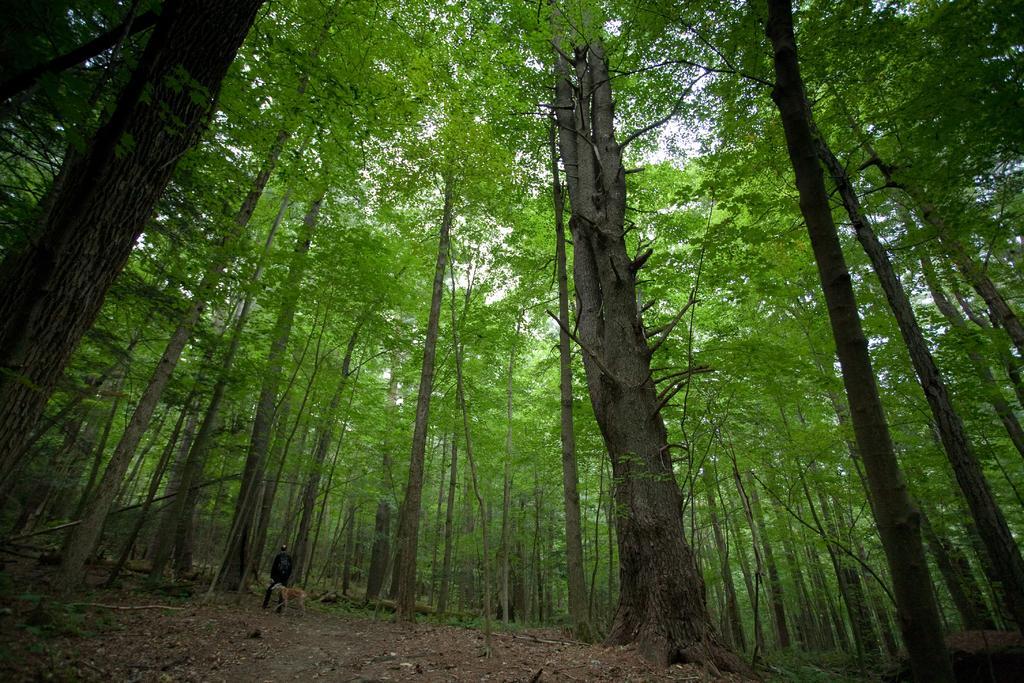Can you describe this image briefly? In this image we can see a person and an animal, there are some trees, grass and the sky. 